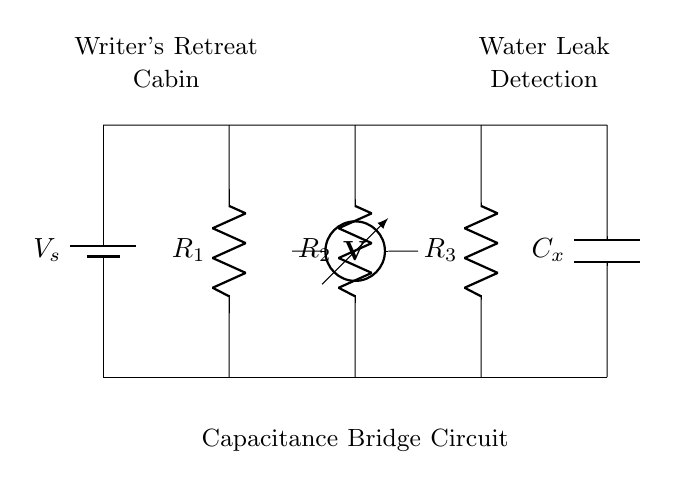What is the source voltage in this circuit? The source voltage \( V_s \) is indicated by the label next to the battery in the diagram.
Answer: V_s What are the resistors labeled in the circuit? The diagram shows three resistors labeled \( R_1 \), \( R_2 \), and \( R_3 \) connected between the top and bottom nodes of the circuit.
Answer: R_1, R_2, R_3 What is connected to the rightmost part of the circuit? The rightmost part of the circuit contains a capacitor labeled \( C_x \), which is connected in series with the resistors.
Answer: C_x How many voltage measurement points are present? There is only one voltmeter shown in the diagram, placed between the nodes connected by two of the resistors.
Answer: One What is the purpose of the bridge circuit in this context? The purpose of the capacitance bridge circuit is to detect water leaks by measuring changes in capacitance caused by water ingress in the cabin.
Answer: Water leak detection What does the voltmeter measure in this circuit? The voltmeter measures the potential difference between the two points in the circuit, specifically across the resistors and capacitor, which helps assess the balance of the bridge.
Answer: Potential difference 